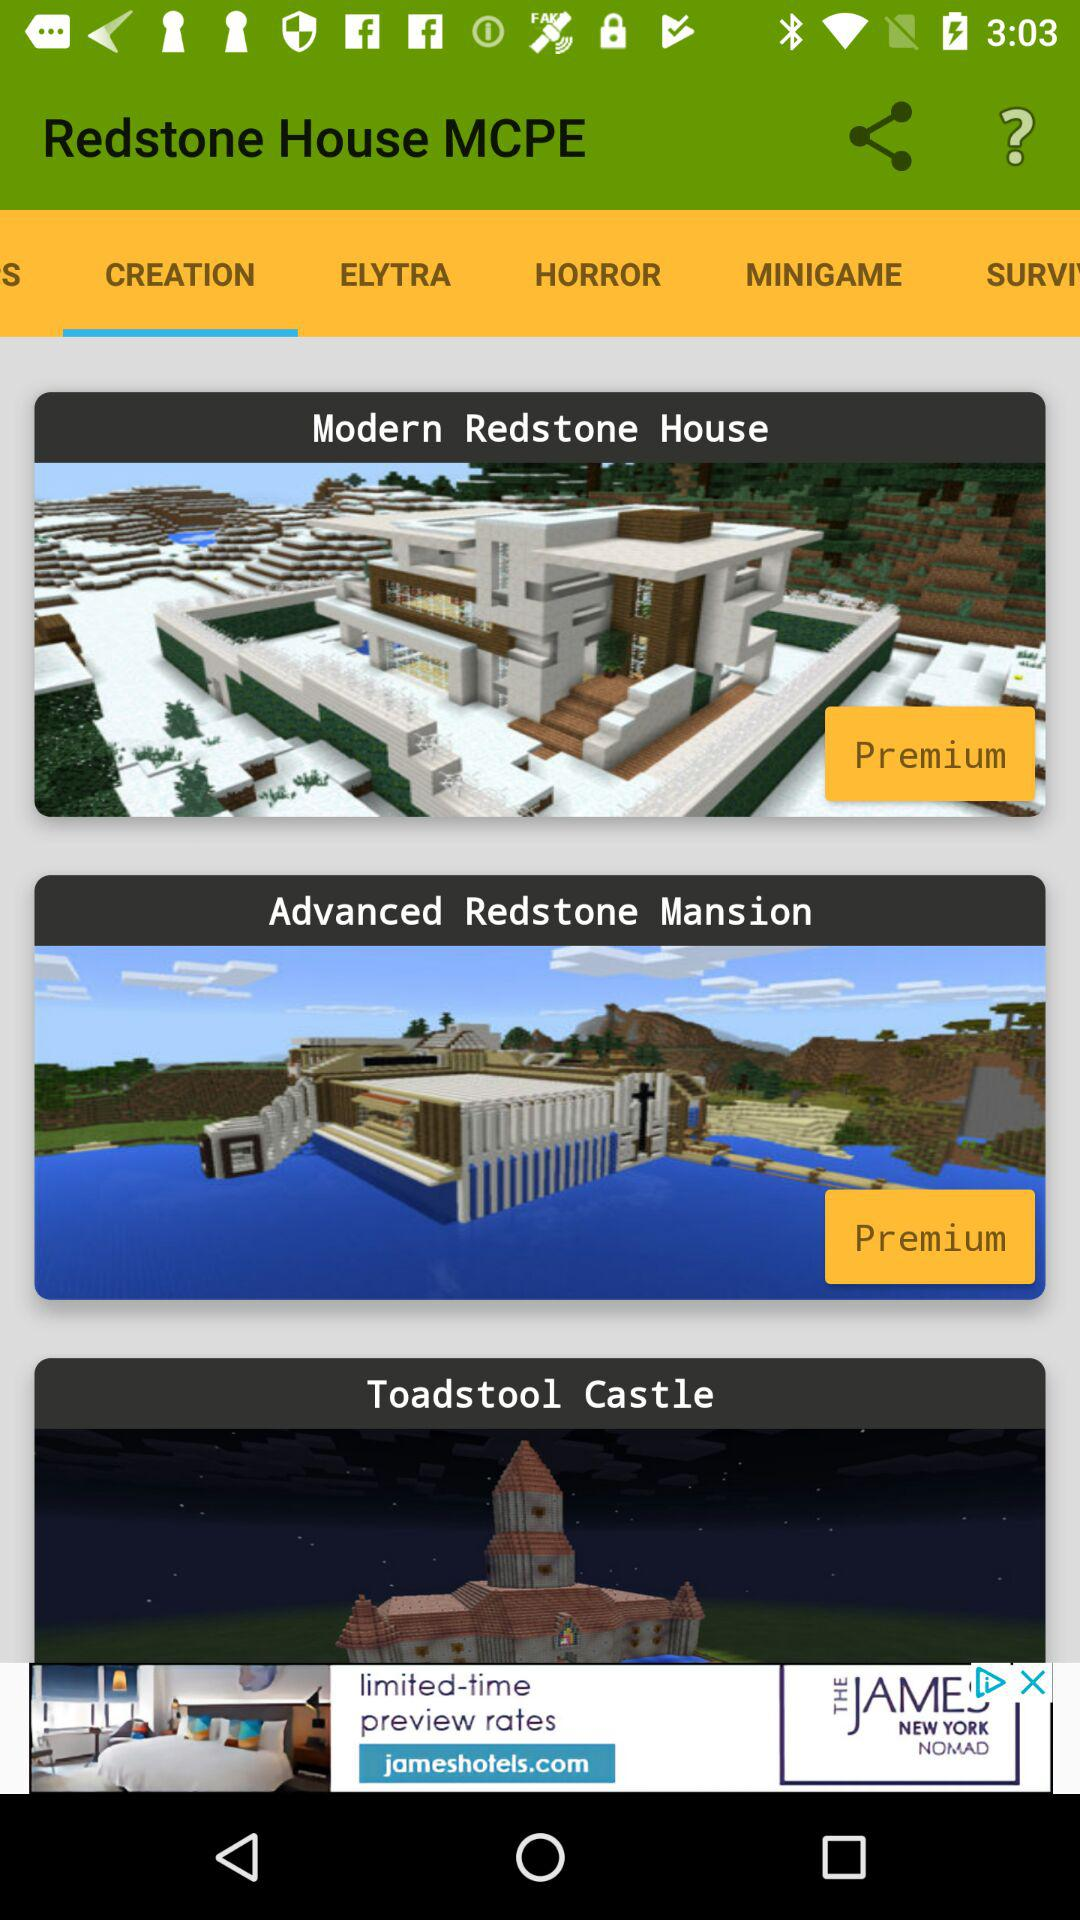What is the application name? The application name is "Redstone House MCPE". 